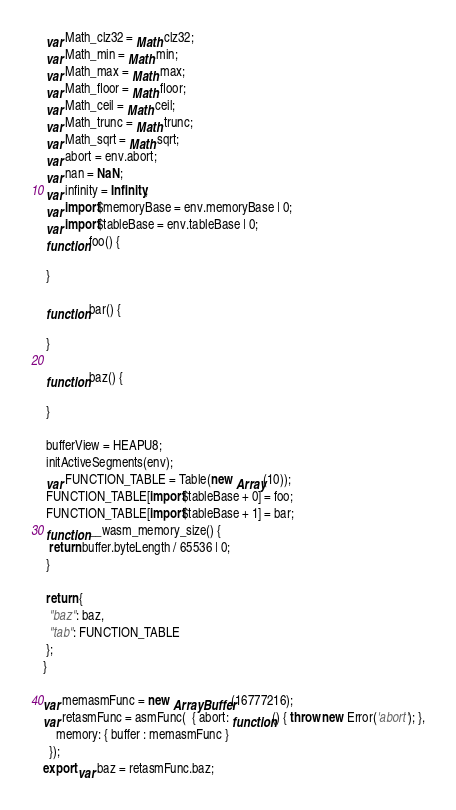<code> <loc_0><loc_0><loc_500><loc_500><_JavaScript_> var Math_clz32 = Math.clz32;
 var Math_min = Math.min;
 var Math_max = Math.max;
 var Math_floor = Math.floor;
 var Math_ceil = Math.ceil;
 var Math_trunc = Math.trunc;
 var Math_sqrt = Math.sqrt;
 var abort = env.abort;
 var nan = NaN;
 var infinity = Infinity;
 var import$memoryBase = env.memoryBase | 0;
 var import$tableBase = env.tableBase | 0;
 function foo() {
  
 }
 
 function bar() {
  
 }
 
 function baz() {
  
 }
 
 bufferView = HEAPU8;
 initActiveSegments(env);
 var FUNCTION_TABLE = Table(new Array(10));
 FUNCTION_TABLE[import$tableBase + 0] = foo;
 FUNCTION_TABLE[import$tableBase + 1] = bar;
 function __wasm_memory_size() {
  return buffer.byteLength / 65536 | 0;
 }
 
 return {
  "baz": baz, 
  "tab": FUNCTION_TABLE
 };
}

var memasmFunc = new ArrayBuffer(16777216);
var retasmFunc = asmFunc(  { abort: function() { throw new Error('abort'); },
    memory: { buffer : memasmFunc }
  });
export var baz = retasmFunc.baz;
</code> 